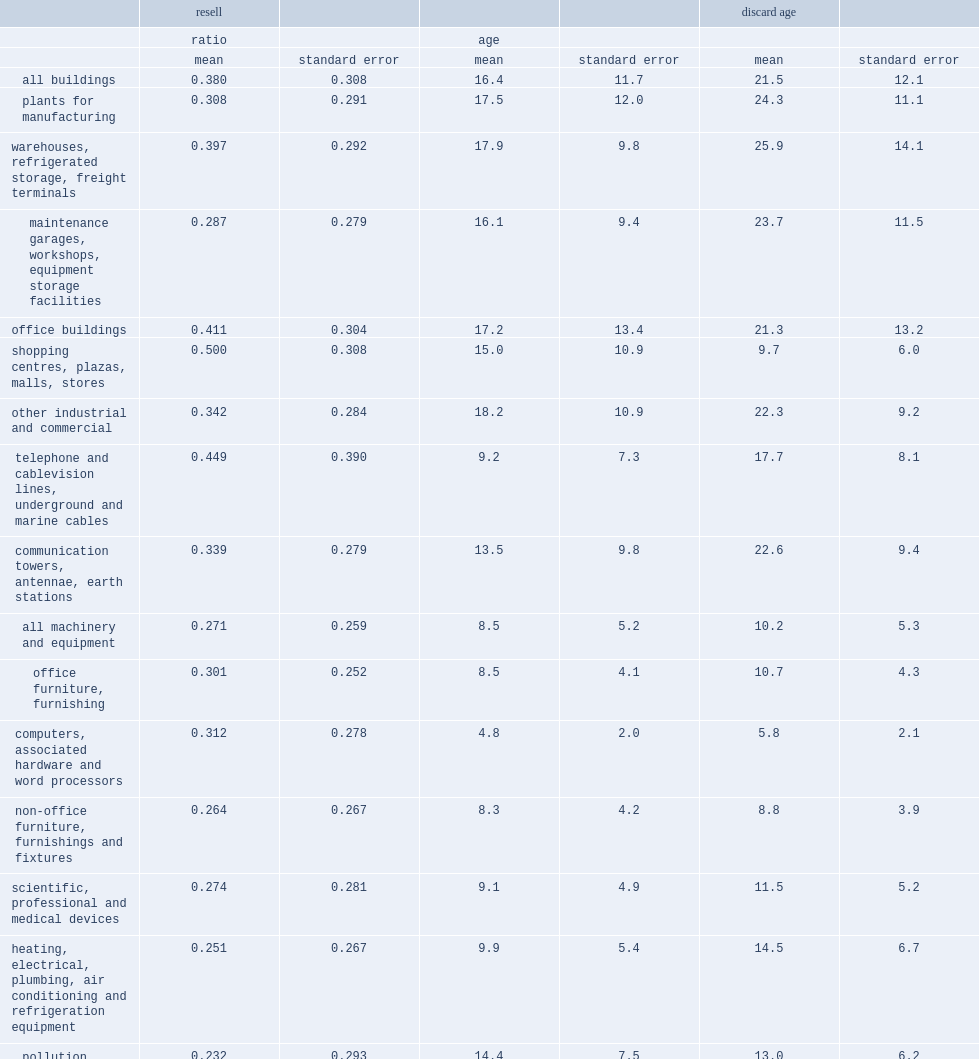From 1985 to 2001, what was the mean reselling price ratio for buildings? 0.38. From 1985 to 2001, what was the mean reselling price ratio for machinery and equipment? 0.271. 